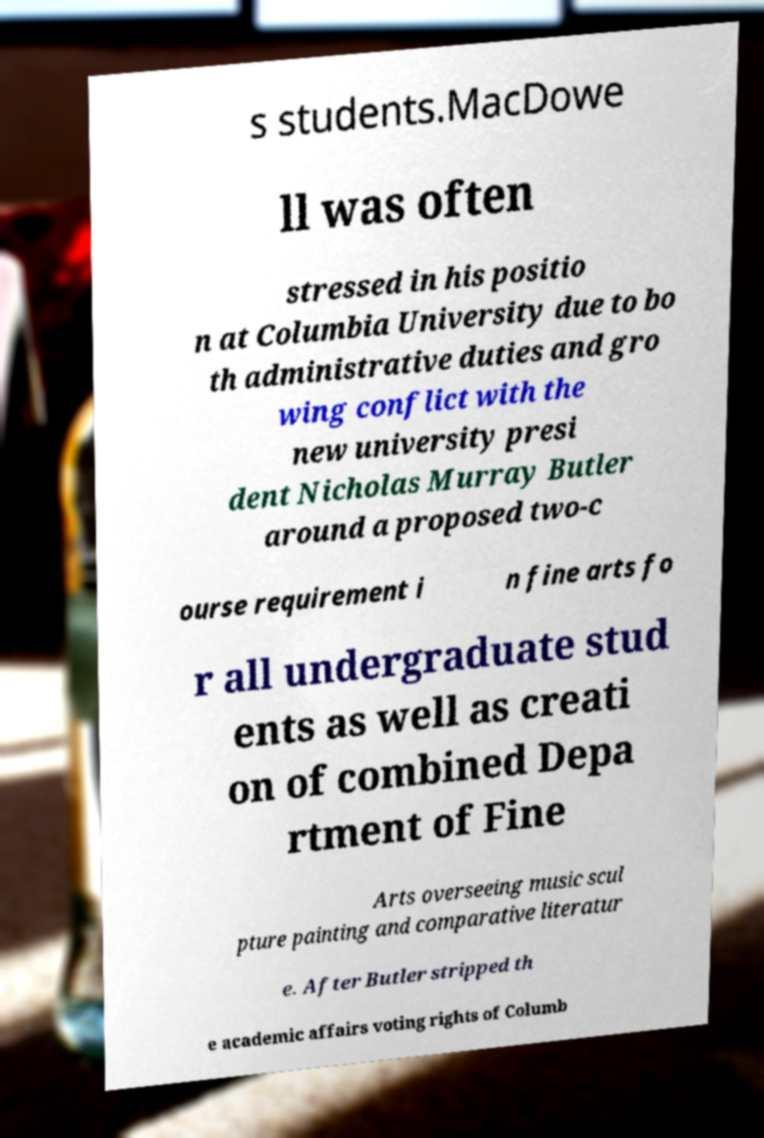Can you read and provide the text displayed in the image?This photo seems to have some interesting text. Can you extract and type it out for me? s students.MacDowe ll was often stressed in his positio n at Columbia University due to bo th administrative duties and gro wing conflict with the new university presi dent Nicholas Murray Butler around a proposed two-c ourse requirement i n fine arts fo r all undergraduate stud ents as well as creati on of combined Depa rtment of Fine Arts overseeing music scul pture painting and comparative literatur e. After Butler stripped th e academic affairs voting rights of Columb 